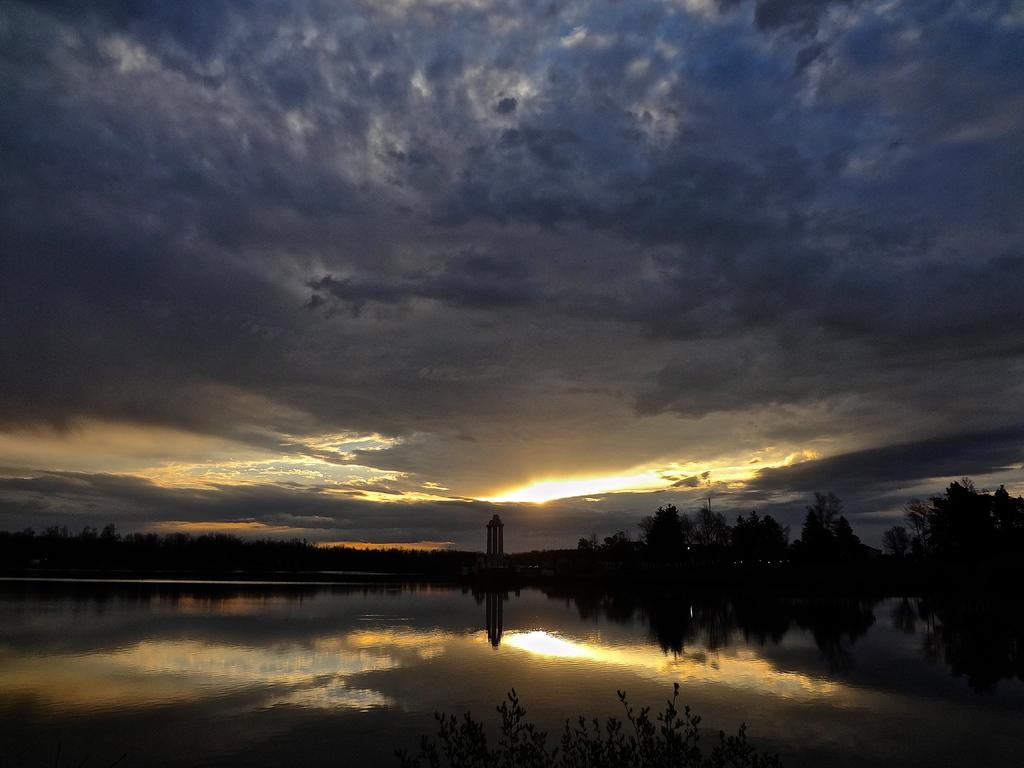What is visible in the image? Water and trees are visible in the image. What time of day is depicted in the image? The image depicts a sunset. How many bears can be seen in the image? There are no bears present in the image. What type of police vehicle is visible in the image? There is no police vehicle present in the image. 